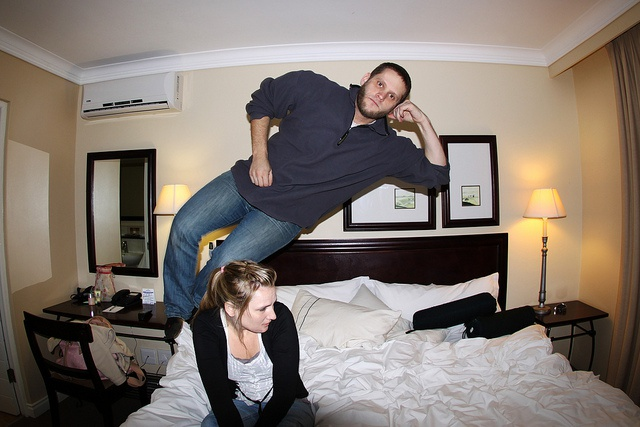Describe the objects in this image and their specific colors. I can see bed in black, lightgray, darkgray, and gray tones, people in black, gray, and blue tones, people in black, lightgray, tan, and darkgray tones, and chair in black, maroon, and brown tones in this image. 